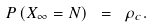<formula> <loc_0><loc_0><loc_500><loc_500>P \, ( X _ { \infty } = N ) \ = \ \rho _ { c } .</formula> 